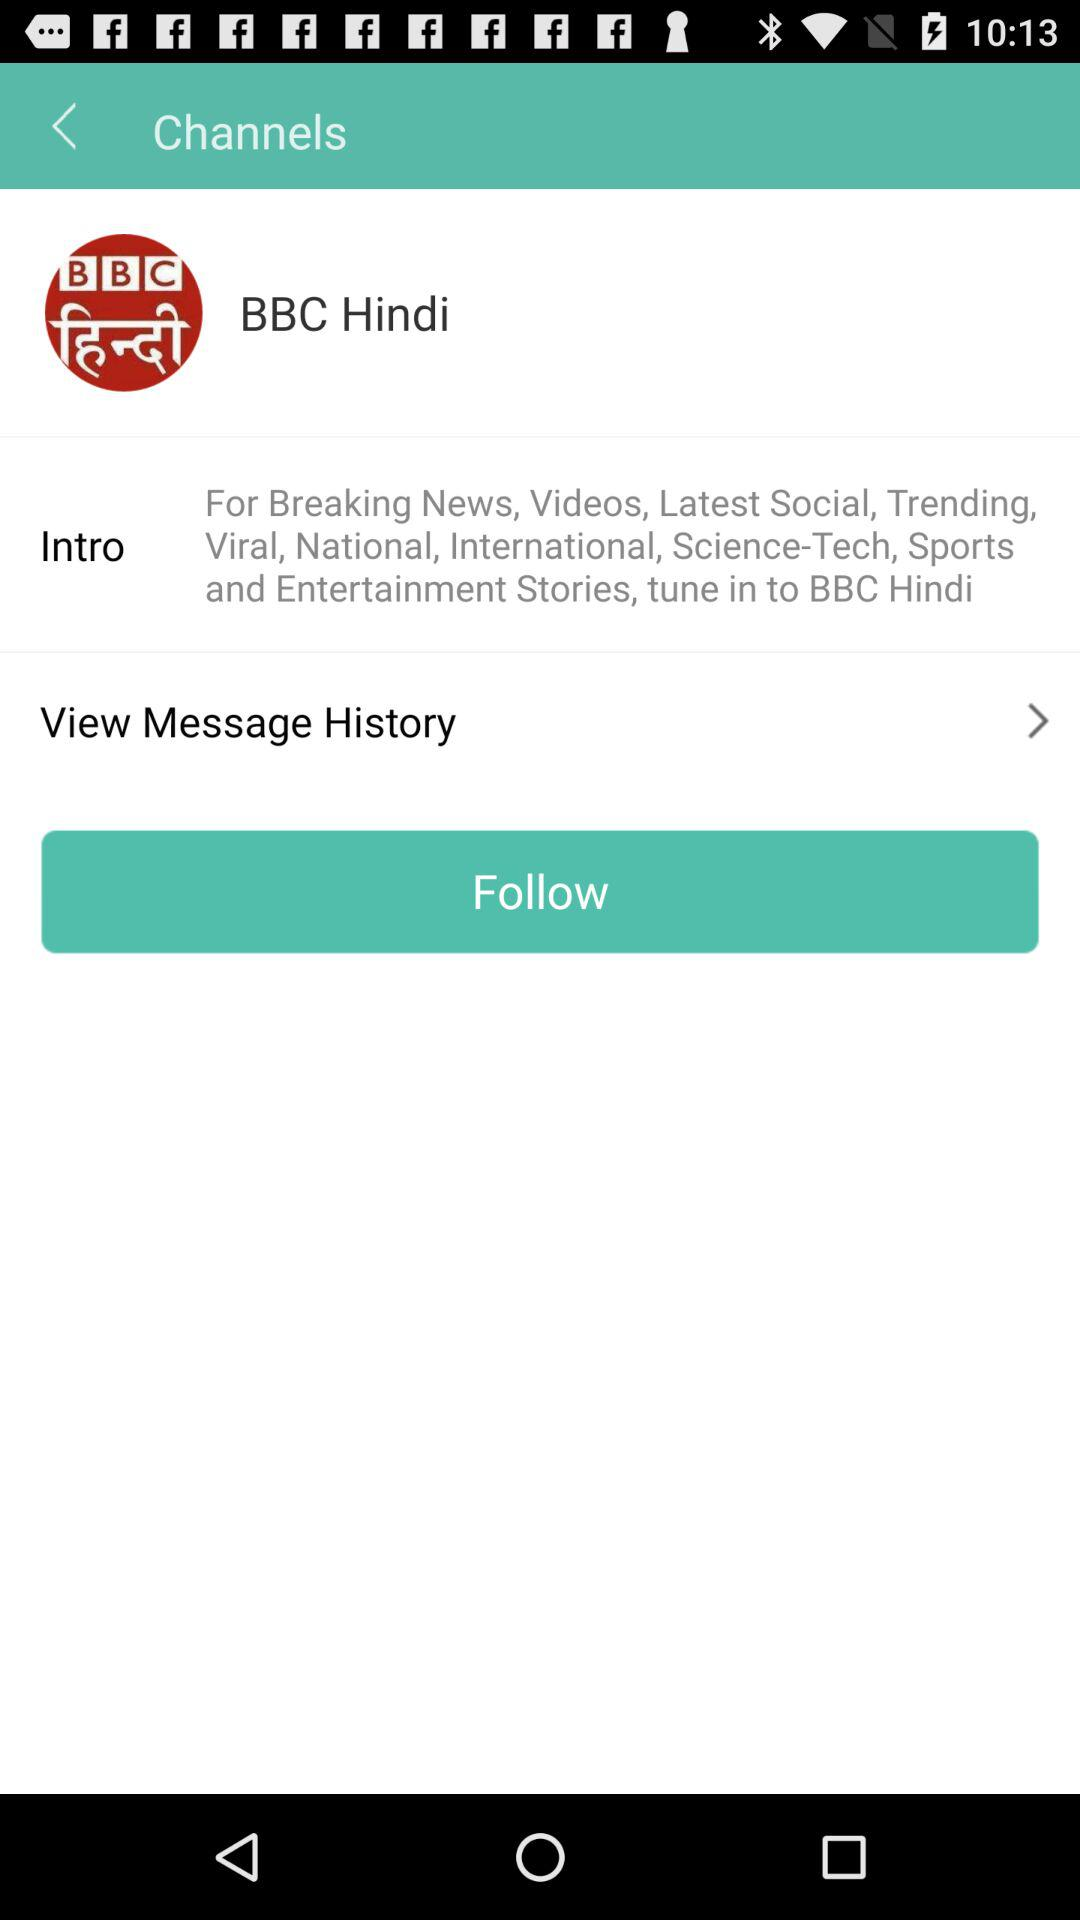What is the news channel name? The news channel name is "BBC Hindi". 